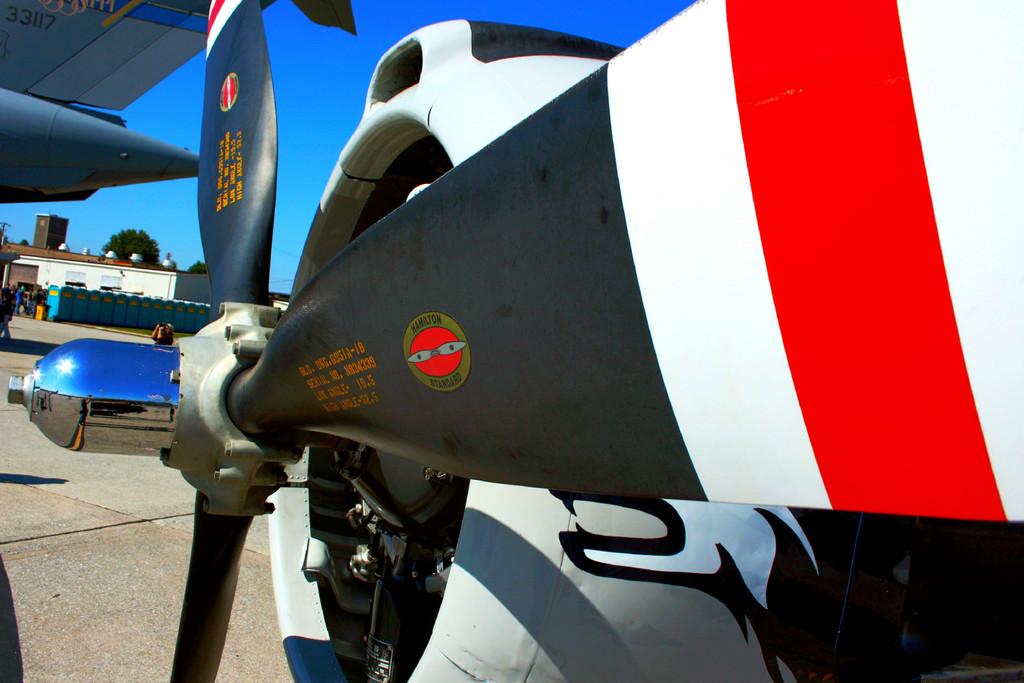What kind of standard is on the round logo?
Offer a very short reply. Hamilton. 